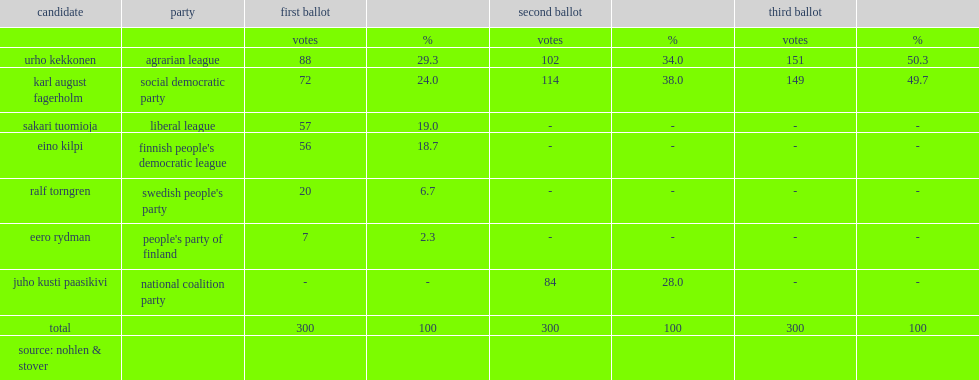How many votes did kekkonen win in the third ballot? 151.0. 